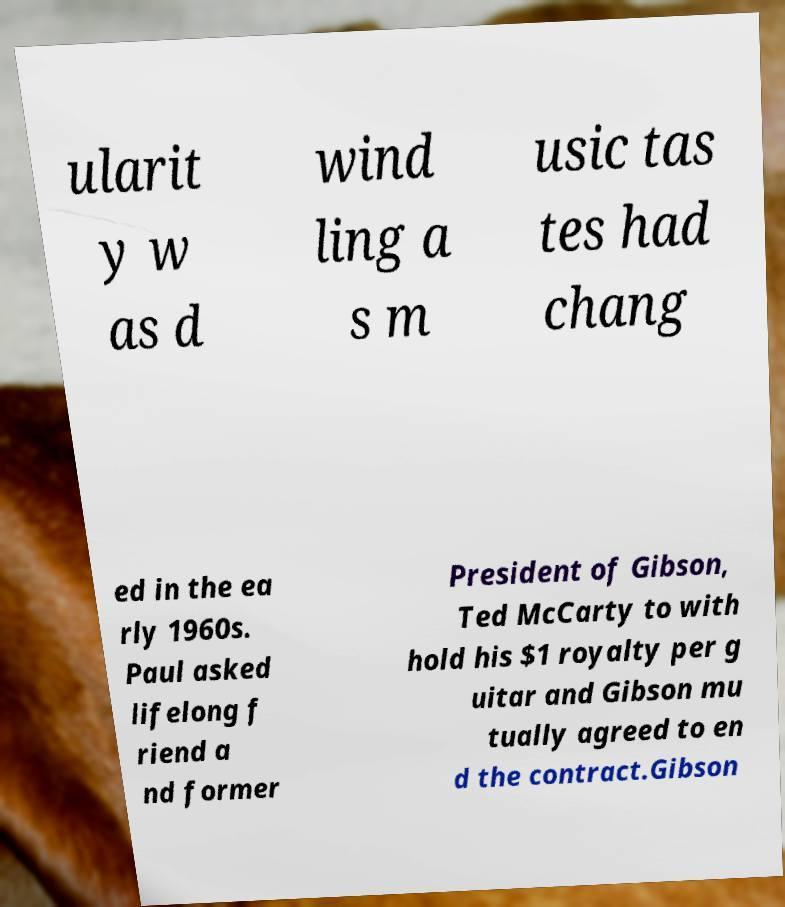For documentation purposes, I need the text within this image transcribed. Could you provide that? ularit y w as d wind ling a s m usic tas tes had chang ed in the ea rly 1960s. Paul asked lifelong f riend a nd former President of Gibson, Ted McCarty to with hold his $1 royalty per g uitar and Gibson mu tually agreed to en d the contract.Gibson 